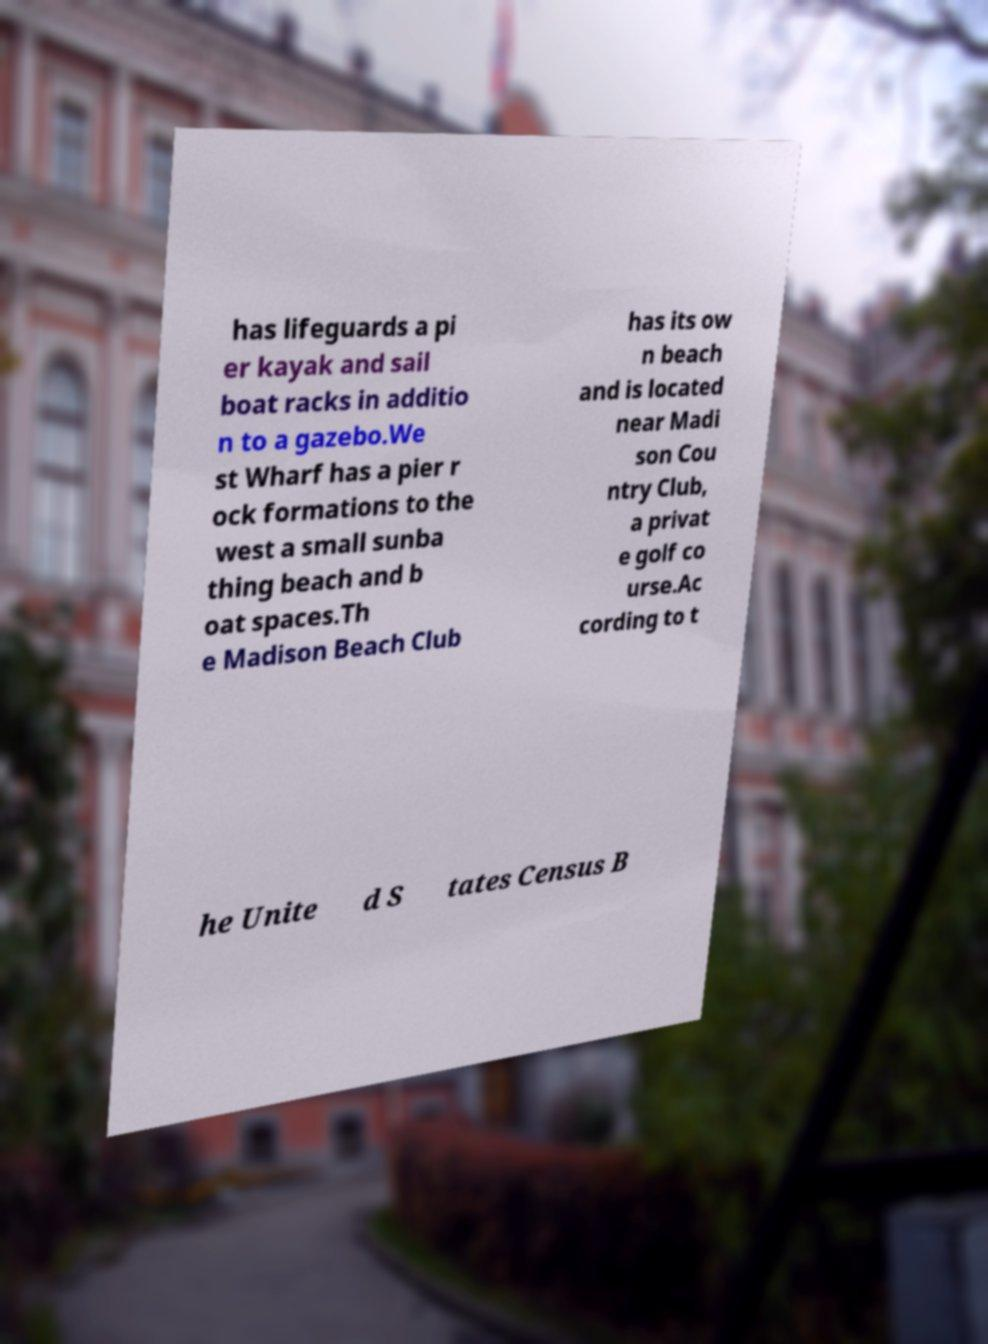Could you extract and type out the text from this image? has lifeguards a pi er kayak and sail boat racks in additio n to a gazebo.We st Wharf has a pier r ock formations to the west a small sunba thing beach and b oat spaces.Th e Madison Beach Club has its ow n beach and is located near Madi son Cou ntry Club, a privat e golf co urse.Ac cording to t he Unite d S tates Census B 